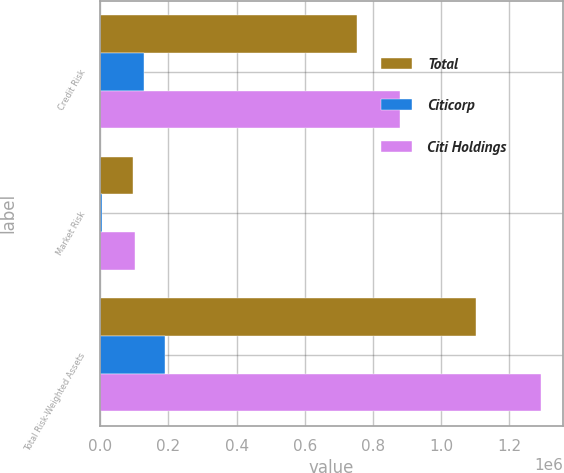Convert chart. <chart><loc_0><loc_0><loc_500><loc_500><stacked_bar_chart><ecel><fcel>Credit Risk<fcel>Market Risk<fcel>Total Risk-Weighted Assets<nl><fcel>Total<fcel>752247<fcel>95824<fcel>1.10323e+06<nl><fcel>Citicorp<fcel>127377<fcel>4657<fcel>189379<nl><fcel>Citi Holdings<fcel>879624<fcel>100481<fcel>1.2926e+06<nl></chart> 